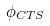Convert formula to latex. <formula><loc_0><loc_0><loc_500><loc_500>\phi _ { C T S }</formula> 